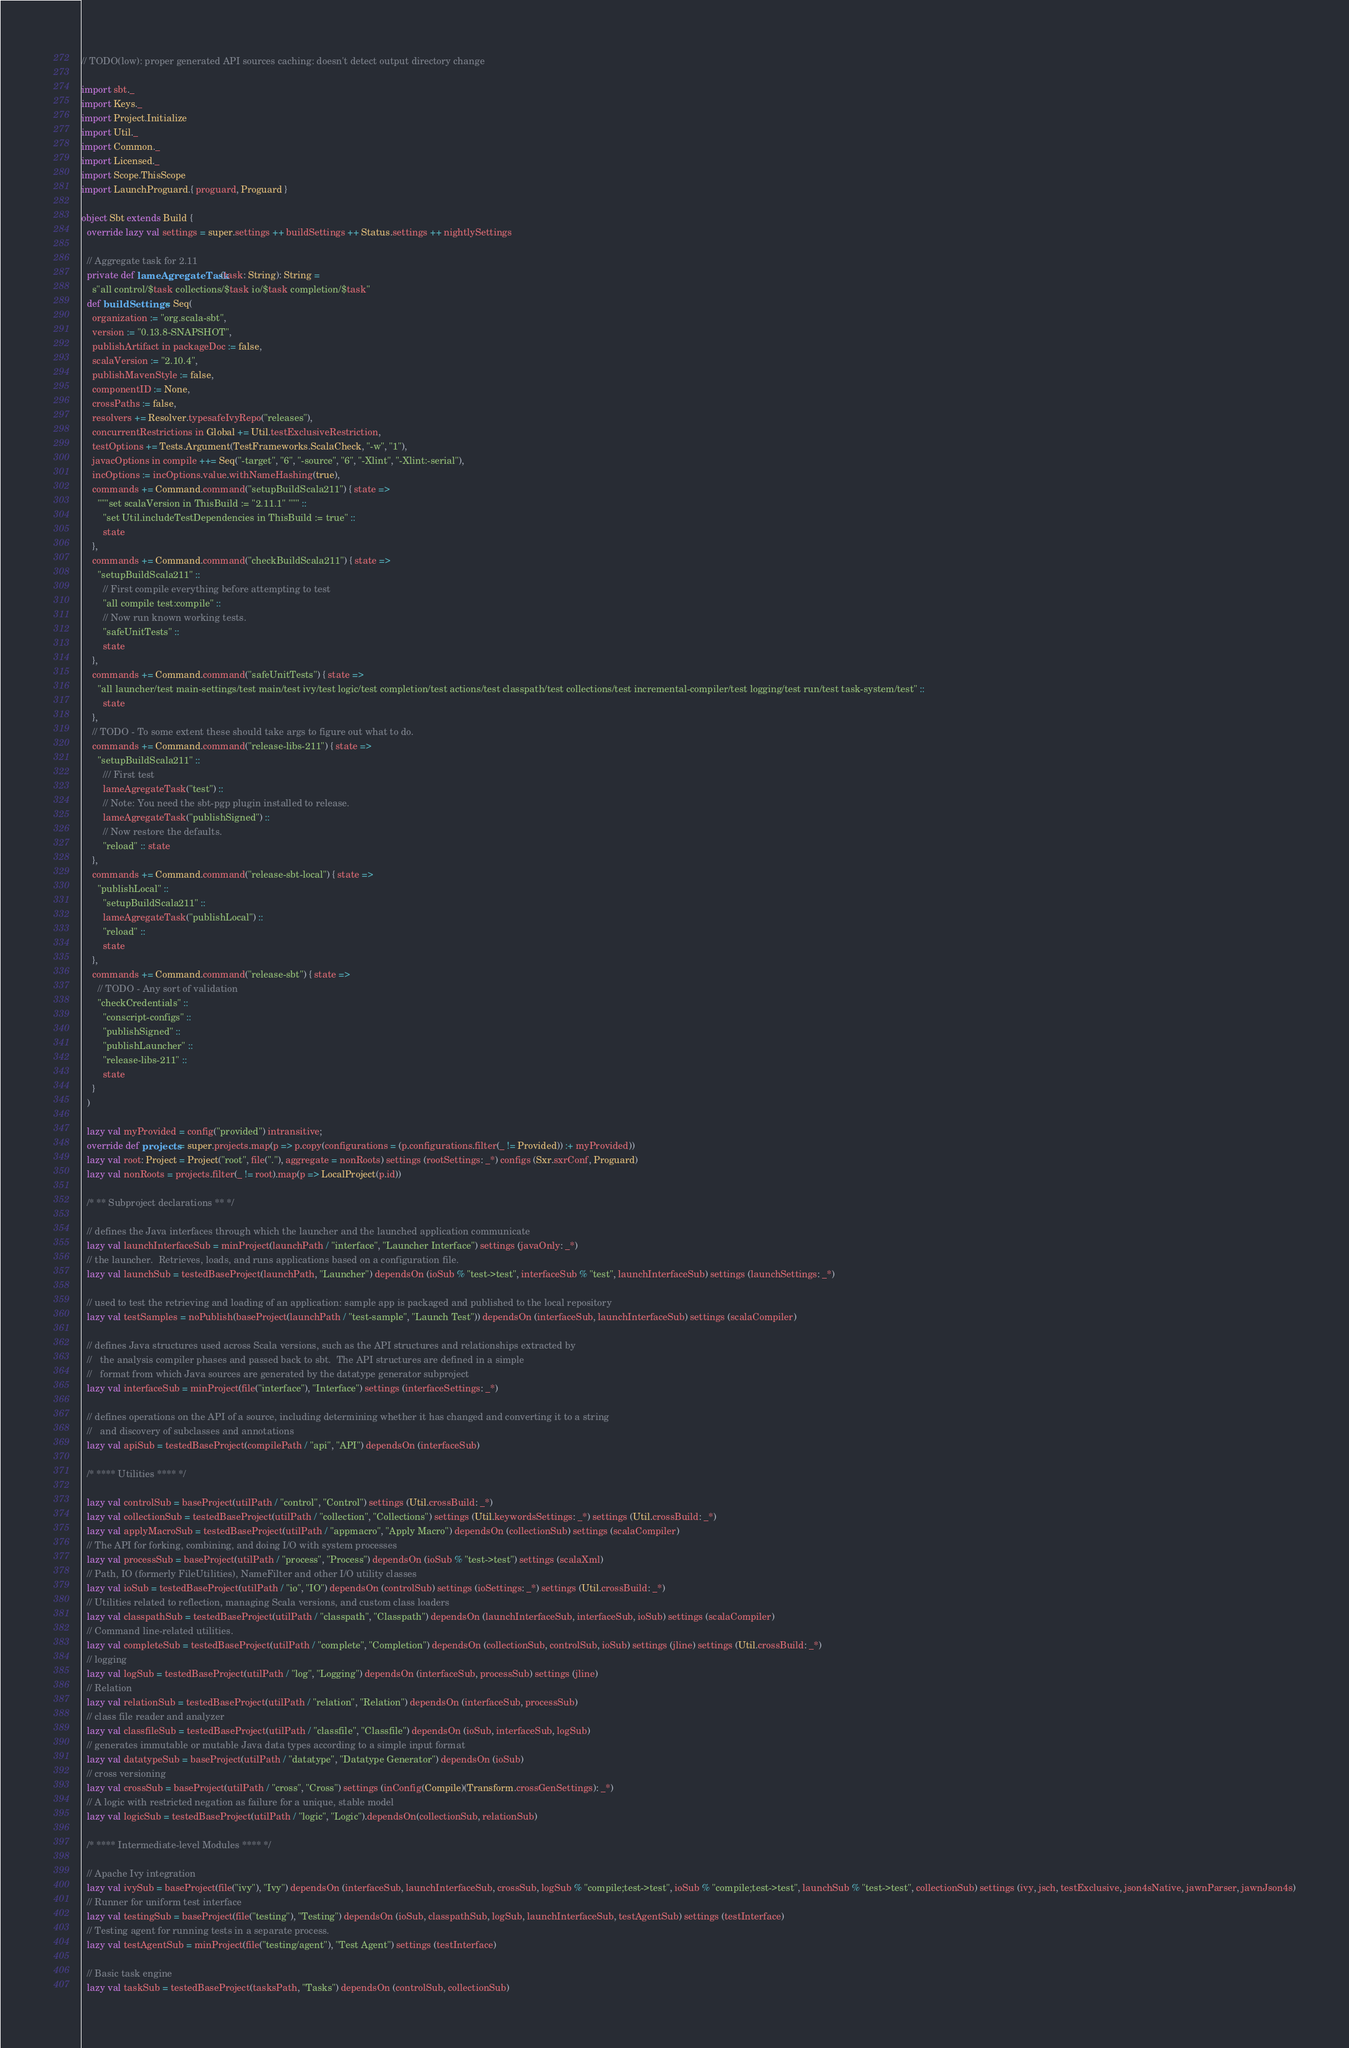Convert code to text. <code><loc_0><loc_0><loc_500><loc_500><_Scala_>// TODO(low): proper generated API sources caching: doesn't detect output directory change

import sbt._
import Keys._
import Project.Initialize
import Util._
import Common._
import Licensed._
import Scope.ThisScope
import LaunchProguard.{ proguard, Proguard }

object Sbt extends Build {
  override lazy val settings = super.settings ++ buildSettings ++ Status.settings ++ nightlySettings

  // Aggregate task for 2.11
  private def lameAgregateTask(task: String): String =
    s"all control/$task collections/$task io/$task completion/$task"
  def buildSettings = Seq(
    organization := "org.scala-sbt",
    version := "0.13.8-SNAPSHOT",
    publishArtifact in packageDoc := false,
    scalaVersion := "2.10.4",
    publishMavenStyle := false,
    componentID := None,
    crossPaths := false,
    resolvers += Resolver.typesafeIvyRepo("releases"),
    concurrentRestrictions in Global += Util.testExclusiveRestriction,
    testOptions += Tests.Argument(TestFrameworks.ScalaCheck, "-w", "1"),
    javacOptions in compile ++= Seq("-target", "6", "-source", "6", "-Xlint", "-Xlint:-serial"),
    incOptions := incOptions.value.withNameHashing(true),
    commands += Command.command("setupBuildScala211") { state =>
      """set scalaVersion in ThisBuild := "2.11.1" """ ::
        "set Util.includeTestDependencies in ThisBuild := true" ::
        state
    },
    commands += Command.command("checkBuildScala211") { state =>
      "setupBuildScala211" ::
        // First compile everything before attempting to test
        "all compile test:compile" ::
        // Now run known working tests.
        "safeUnitTests" ::
        state
    },
    commands += Command.command("safeUnitTests") { state =>
      "all launcher/test main-settings/test main/test ivy/test logic/test completion/test actions/test classpath/test collections/test incremental-compiler/test logging/test run/test task-system/test" ::
        state
    },
    // TODO - To some extent these should take args to figure out what to do.
    commands += Command.command("release-libs-211") { state =>
      "setupBuildScala211" ::
        /// First test
        lameAgregateTask("test") ::
        // Note: You need the sbt-pgp plugin installed to release.
        lameAgregateTask("publishSigned") ::
        // Now restore the defaults.
        "reload" :: state
    },
    commands += Command.command("release-sbt-local") { state =>
      "publishLocal" ::
        "setupBuildScala211" ::
        lameAgregateTask("publishLocal") ::
        "reload" ::
        state
    },
    commands += Command.command("release-sbt") { state =>
      // TODO - Any sort of validation
      "checkCredentials" ::
        "conscript-configs" ::
        "publishSigned" ::
        "publishLauncher" ::
        "release-libs-211" ::
        state
    }
  )

  lazy val myProvided = config("provided") intransitive;
  override def projects = super.projects.map(p => p.copy(configurations = (p.configurations.filter(_ != Provided)) :+ myProvided))
  lazy val root: Project = Project("root", file("."), aggregate = nonRoots) settings (rootSettings: _*) configs (Sxr.sxrConf, Proguard)
  lazy val nonRoots = projects.filter(_ != root).map(p => LocalProject(p.id))

  /* ** Subproject declarations ** */

  // defines the Java interfaces through which the launcher and the launched application communicate
  lazy val launchInterfaceSub = minProject(launchPath / "interface", "Launcher Interface") settings (javaOnly: _*)
  // the launcher.  Retrieves, loads, and runs applications based on a configuration file.
  lazy val launchSub = testedBaseProject(launchPath, "Launcher") dependsOn (ioSub % "test->test", interfaceSub % "test", launchInterfaceSub) settings (launchSettings: _*)

  // used to test the retrieving and loading of an application: sample app is packaged and published to the local repository
  lazy val testSamples = noPublish(baseProject(launchPath / "test-sample", "Launch Test")) dependsOn (interfaceSub, launchInterfaceSub) settings (scalaCompiler)

  // defines Java structures used across Scala versions, such as the API structures and relationships extracted by
  //   the analysis compiler phases and passed back to sbt.  The API structures are defined in a simple
  //   format from which Java sources are generated by the datatype generator subproject
  lazy val interfaceSub = minProject(file("interface"), "Interface") settings (interfaceSettings: _*)

  // defines operations on the API of a source, including determining whether it has changed and converting it to a string
  //   and discovery of subclasses and annotations
  lazy val apiSub = testedBaseProject(compilePath / "api", "API") dependsOn (interfaceSub)

  /* **** Utilities **** */

  lazy val controlSub = baseProject(utilPath / "control", "Control") settings (Util.crossBuild: _*)
  lazy val collectionSub = testedBaseProject(utilPath / "collection", "Collections") settings (Util.keywordsSettings: _*) settings (Util.crossBuild: _*)
  lazy val applyMacroSub = testedBaseProject(utilPath / "appmacro", "Apply Macro") dependsOn (collectionSub) settings (scalaCompiler)
  // The API for forking, combining, and doing I/O with system processes
  lazy val processSub = baseProject(utilPath / "process", "Process") dependsOn (ioSub % "test->test") settings (scalaXml)
  // Path, IO (formerly FileUtilities), NameFilter and other I/O utility classes
  lazy val ioSub = testedBaseProject(utilPath / "io", "IO") dependsOn (controlSub) settings (ioSettings: _*) settings (Util.crossBuild: _*)
  // Utilities related to reflection, managing Scala versions, and custom class loaders
  lazy val classpathSub = testedBaseProject(utilPath / "classpath", "Classpath") dependsOn (launchInterfaceSub, interfaceSub, ioSub) settings (scalaCompiler)
  // Command line-related utilities.
  lazy val completeSub = testedBaseProject(utilPath / "complete", "Completion") dependsOn (collectionSub, controlSub, ioSub) settings (jline) settings (Util.crossBuild: _*)
  // logging
  lazy val logSub = testedBaseProject(utilPath / "log", "Logging") dependsOn (interfaceSub, processSub) settings (jline)
  // Relation
  lazy val relationSub = testedBaseProject(utilPath / "relation", "Relation") dependsOn (interfaceSub, processSub)
  // class file reader and analyzer
  lazy val classfileSub = testedBaseProject(utilPath / "classfile", "Classfile") dependsOn (ioSub, interfaceSub, logSub)
  // generates immutable or mutable Java data types according to a simple input format
  lazy val datatypeSub = baseProject(utilPath / "datatype", "Datatype Generator") dependsOn (ioSub)
  // cross versioning
  lazy val crossSub = baseProject(utilPath / "cross", "Cross") settings (inConfig(Compile)(Transform.crossGenSettings): _*)
  // A logic with restricted negation as failure for a unique, stable model
  lazy val logicSub = testedBaseProject(utilPath / "logic", "Logic").dependsOn(collectionSub, relationSub)

  /* **** Intermediate-level Modules **** */

  // Apache Ivy integration
  lazy val ivySub = baseProject(file("ivy"), "Ivy") dependsOn (interfaceSub, launchInterfaceSub, crossSub, logSub % "compile;test->test", ioSub % "compile;test->test", launchSub % "test->test", collectionSub) settings (ivy, jsch, testExclusive, json4sNative, jawnParser, jawnJson4s)
  // Runner for uniform test interface
  lazy val testingSub = baseProject(file("testing"), "Testing") dependsOn (ioSub, classpathSub, logSub, launchInterfaceSub, testAgentSub) settings (testInterface)
  // Testing agent for running tests in a separate process.
  lazy val testAgentSub = minProject(file("testing/agent"), "Test Agent") settings (testInterface)

  // Basic task engine
  lazy val taskSub = testedBaseProject(tasksPath, "Tasks") dependsOn (controlSub, collectionSub)</code> 